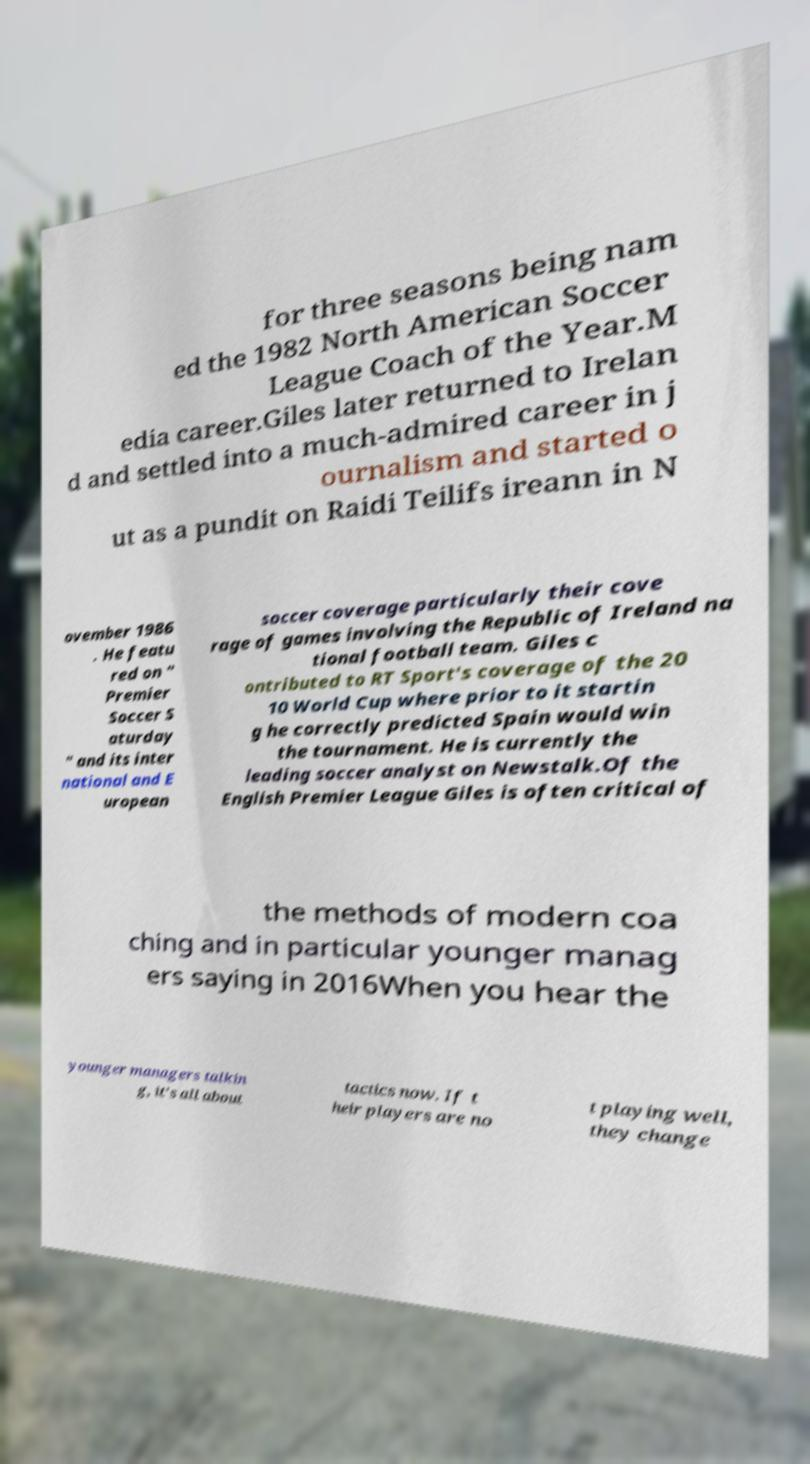Could you assist in decoding the text presented in this image and type it out clearly? for three seasons being nam ed the 1982 North American Soccer League Coach of the Year.M edia career.Giles later returned to Irelan d and settled into a much-admired career in j ournalism and started o ut as a pundit on Raidi Teilifs ireann in N ovember 1986 . He featu red on " Premier Soccer S aturday " and its inter national and E uropean soccer coverage particularly their cove rage of games involving the Republic of Ireland na tional football team. Giles c ontributed to RT Sport's coverage of the 20 10 World Cup where prior to it startin g he correctly predicted Spain would win the tournament. He is currently the leading soccer analyst on Newstalk.Of the English Premier League Giles is often critical of the methods of modern coa ching and in particular younger manag ers saying in 2016When you hear the younger managers talkin g, it's all about tactics now. If t heir players are no t playing well, they change 